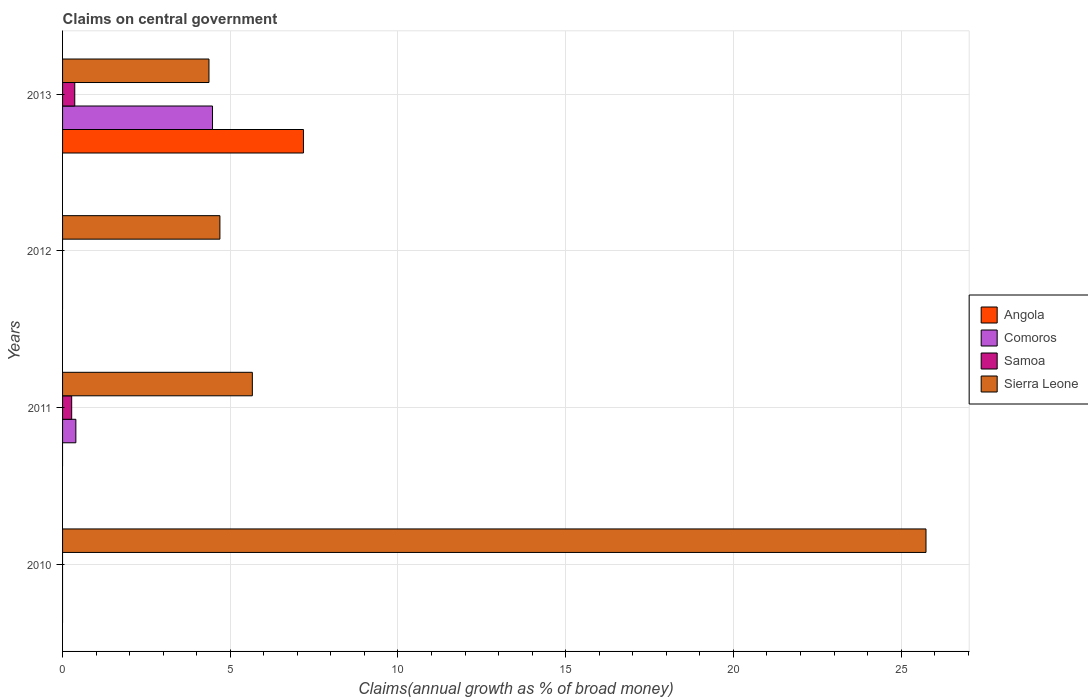How many different coloured bars are there?
Your response must be concise. 4. Are the number of bars per tick equal to the number of legend labels?
Your response must be concise. No. How many bars are there on the 2nd tick from the top?
Your response must be concise. 1. What is the label of the 3rd group of bars from the top?
Offer a terse response. 2011. What is the percentage of broad money claimed on centeral government in Comoros in 2011?
Your answer should be compact. 0.4. Across all years, what is the maximum percentage of broad money claimed on centeral government in Samoa?
Give a very brief answer. 0.36. Across all years, what is the minimum percentage of broad money claimed on centeral government in Samoa?
Your response must be concise. 0. What is the total percentage of broad money claimed on centeral government in Angola in the graph?
Offer a terse response. 7.18. What is the difference between the percentage of broad money claimed on centeral government in Samoa in 2011 and that in 2013?
Ensure brevity in your answer.  -0.09. What is the difference between the percentage of broad money claimed on centeral government in Comoros in 2011 and the percentage of broad money claimed on centeral government in Angola in 2012?
Make the answer very short. 0.4. What is the average percentage of broad money claimed on centeral government in Comoros per year?
Give a very brief answer. 1.22. In the year 2013, what is the difference between the percentage of broad money claimed on centeral government in Angola and percentage of broad money claimed on centeral government in Comoros?
Ensure brevity in your answer.  2.71. What is the ratio of the percentage of broad money claimed on centeral government in Sierra Leone in 2011 to that in 2013?
Ensure brevity in your answer.  1.3. Is the percentage of broad money claimed on centeral government in Sierra Leone in 2012 less than that in 2013?
Make the answer very short. No. What is the difference between the highest and the second highest percentage of broad money claimed on centeral government in Sierra Leone?
Offer a terse response. 20.08. What is the difference between the highest and the lowest percentage of broad money claimed on centeral government in Comoros?
Provide a short and direct response. 4.47. How many bars are there?
Provide a succinct answer. 9. How many years are there in the graph?
Keep it short and to the point. 4. Are the values on the major ticks of X-axis written in scientific E-notation?
Make the answer very short. No. How many legend labels are there?
Provide a short and direct response. 4. What is the title of the graph?
Your answer should be very brief. Claims on central government. What is the label or title of the X-axis?
Keep it short and to the point. Claims(annual growth as % of broad money). What is the Claims(annual growth as % of broad money) in Sierra Leone in 2010?
Your answer should be compact. 25.74. What is the Claims(annual growth as % of broad money) of Comoros in 2011?
Provide a succinct answer. 0.4. What is the Claims(annual growth as % of broad money) of Samoa in 2011?
Keep it short and to the point. 0.27. What is the Claims(annual growth as % of broad money) of Sierra Leone in 2011?
Provide a short and direct response. 5.66. What is the Claims(annual growth as % of broad money) of Angola in 2012?
Your response must be concise. 0. What is the Claims(annual growth as % of broad money) in Comoros in 2012?
Ensure brevity in your answer.  0. What is the Claims(annual growth as % of broad money) of Samoa in 2012?
Make the answer very short. 0. What is the Claims(annual growth as % of broad money) of Sierra Leone in 2012?
Your answer should be very brief. 4.69. What is the Claims(annual growth as % of broad money) in Angola in 2013?
Offer a very short reply. 7.18. What is the Claims(annual growth as % of broad money) in Comoros in 2013?
Ensure brevity in your answer.  4.47. What is the Claims(annual growth as % of broad money) in Samoa in 2013?
Provide a short and direct response. 0.36. What is the Claims(annual growth as % of broad money) in Sierra Leone in 2013?
Provide a short and direct response. 4.36. Across all years, what is the maximum Claims(annual growth as % of broad money) of Angola?
Ensure brevity in your answer.  7.18. Across all years, what is the maximum Claims(annual growth as % of broad money) in Comoros?
Give a very brief answer. 4.47. Across all years, what is the maximum Claims(annual growth as % of broad money) in Samoa?
Make the answer very short. 0.36. Across all years, what is the maximum Claims(annual growth as % of broad money) of Sierra Leone?
Keep it short and to the point. 25.74. Across all years, what is the minimum Claims(annual growth as % of broad money) of Comoros?
Provide a short and direct response. 0. Across all years, what is the minimum Claims(annual growth as % of broad money) of Sierra Leone?
Ensure brevity in your answer.  4.36. What is the total Claims(annual growth as % of broad money) of Angola in the graph?
Provide a short and direct response. 7.18. What is the total Claims(annual growth as % of broad money) in Comoros in the graph?
Make the answer very short. 4.87. What is the total Claims(annual growth as % of broad money) in Samoa in the graph?
Offer a terse response. 0.64. What is the total Claims(annual growth as % of broad money) of Sierra Leone in the graph?
Keep it short and to the point. 40.46. What is the difference between the Claims(annual growth as % of broad money) of Sierra Leone in 2010 and that in 2011?
Give a very brief answer. 20.08. What is the difference between the Claims(annual growth as % of broad money) of Sierra Leone in 2010 and that in 2012?
Provide a short and direct response. 21.05. What is the difference between the Claims(annual growth as % of broad money) in Sierra Leone in 2010 and that in 2013?
Your response must be concise. 21.38. What is the difference between the Claims(annual growth as % of broad money) of Sierra Leone in 2011 and that in 2012?
Your response must be concise. 0.97. What is the difference between the Claims(annual growth as % of broad money) in Comoros in 2011 and that in 2013?
Offer a terse response. -4.07. What is the difference between the Claims(annual growth as % of broad money) of Samoa in 2011 and that in 2013?
Your response must be concise. -0.09. What is the difference between the Claims(annual growth as % of broad money) in Sierra Leone in 2011 and that in 2013?
Offer a terse response. 1.29. What is the difference between the Claims(annual growth as % of broad money) in Sierra Leone in 2012 and that in 2013?
Offer a very short reply. 0.33. What is the difference between the Claims(annual growth as % of broad money) of Comoros in 2011 and the Claims(annual growth as % of broad money) of Sierra Leone in 2012?
Ensure brevity in your answer.  -4.29. What is the difference between the Claims(annual growth as % of broad money) of Samoa in 2011 and the Claims(annual growth as % of broad money) of Sierra Leone in 2012?
Provide a short and direct response. -4.42. What is the difference between the Claims(annual growth as % of broad money) of Comoros in 2011 and the Claims(annual growth as % of broad money) of Samoa in 2013?
Provide a succinct answer. 0.03. What is the difference between the Claims(annual growth as % of broad money) of Comoros in 2011 and the Claims(annual growth as % of broad money) of Sierra Leone in 2013?
Provide a succinct answer. -3.97. What is the difference between the Claims(annual growth as % of broad money) of Samoa in 2011 and the Claims(annual growth as % of broad money) of Sierra Leone in 2013?
Keep it short and to the point. -4.09. What is the average Claims(annual growth as % of broad money) in Angola per year?
Provide a succinct answer. 1.8. What is the average Claims(annual growth as % of broad money) of Comoros per year?
Keep it short and to the point. 1.22. What is the average Claims(annual growth as % of broad money) in Samoa per year?
Give a very brief answer. 0.16. What is the average Claims(annual growth as % of broad money) in Sierra Leone per year?
Your response must be concise. 10.11. In the year 2011, what is the difference between the Claims(annual growth as % of broad money) in Comoros and Claims(annual growth as % of broad money) in Samoa?
Ensure brevity in your answer.  0.12. In the year 2011, what is the difference between the Claims(annual growth as % of broad money) of Comoros and Claims(annual growth as % of broad money) of Sierra Leone?
Offer a terse response. -5.26. In the year 2011, what is the difference between the Claims(annual growth as % of broad money) in Samoa and Claims(annual growth as % of broad money) in Sierra Leone?
Ensure brevity in your answer.  -5.39. In the year 2013, what is the difference between the Claims(annual growth as % of broad money) of Angola and Claims(annual growth as % of broad money) of Comoros?
Keep it short and to the point. 2.71. In the year 2013, what is the difference between the Claims(annual growth as % of broad money) in Angola and Claims(annual growth as % of broad money) in Samoa?
Make the answer very short. 6.82. In the year 2013, what is the difference between the Claims(annual growth as % of broad money) of Angola and Claims(annual growth as % of broad money) of Sierra Leone?
Offer a very short reply. 2.82. In the year 2013, what is the difference between the Claims(annual growth as % of broad money) in Comoros and Claims(annual growth as % of broad money) in Samoa?
Ensure brevity in your answer.  4.11. In the year 2013, what is the difference between the Claims(annual growth as % of broad money) in Comoros and Claims(annual growth as % of broad money) in Sierra Leone?
Give a very brief answer. 0.11. In the year 2013, what is the difference between the Claims(annual growth as % of broad money) of Samoa and Claims(annual growth as % of broad money) of Sierra Leone?
Provide a succinct answer. -4. What is the ratio of the Claims(annual growth as % of broad money) of Sierra Leone in 2010 to that in 2011?
Make the answer very short. 4.55. What is the ratio of the Claims(annual growth as % of broad money) in Sierra Leone in 2010 to that in 2012?
Ensure brevity in your answer.  5.49. What is the ratio of the Claims(annual growth as % of broad money) in Sierra Leone in 2010 to that in 2013?
Offer a terse response. 5.9. What is the ratio of the Claims(annual growth as % of broad money) in Sierra Leone in 2011 to that in 2012?
Offer a very short reply. 1.21. What is the ratio of the Claims(annual growth as % of broad money) of Comoros in 2011 to that in 2013?
Offer a terse response. 0.09. What is the ratio of the Claims(annual growth as % of broad money) of Samoa in 2011 to that in 2013?
Your response must be concise. 0.75. What is the ratio of the Claims(annual growth as % of broad money) in Sierra Leone in 2011 to that in 2013?
Provide a succinct answer. 1.3. What is the ratio of the Claims(annual growth as % of broad money) of Sierra Leone in 2012 to that in 2013?
Keep it short and to the point. 1.07. What is the difference between the highest and the second highest Claims(annual growth as % of broad money) in Sierra Leone?
Ensure brevity in your answer.  20.08. What is the difference between the highest and the lowest Claims(annual growth as % of broad money) in Angola?
Your answer should be very brief. 7.18. What is the difference between the highest and the lowest Claims(annual growth as % of broad money) in Comoros?
Your response must be concise. 4.47. What is the difference between the highest and the lowest Claims(annual growth as % of broad money) of Samoa?
Ensure brevity in your answer.  0.36. What is the difference between the highest and the lowest Claims(annual growth as % of broad money) of Sierra Leone?
Your response must be concise. 21.38. 